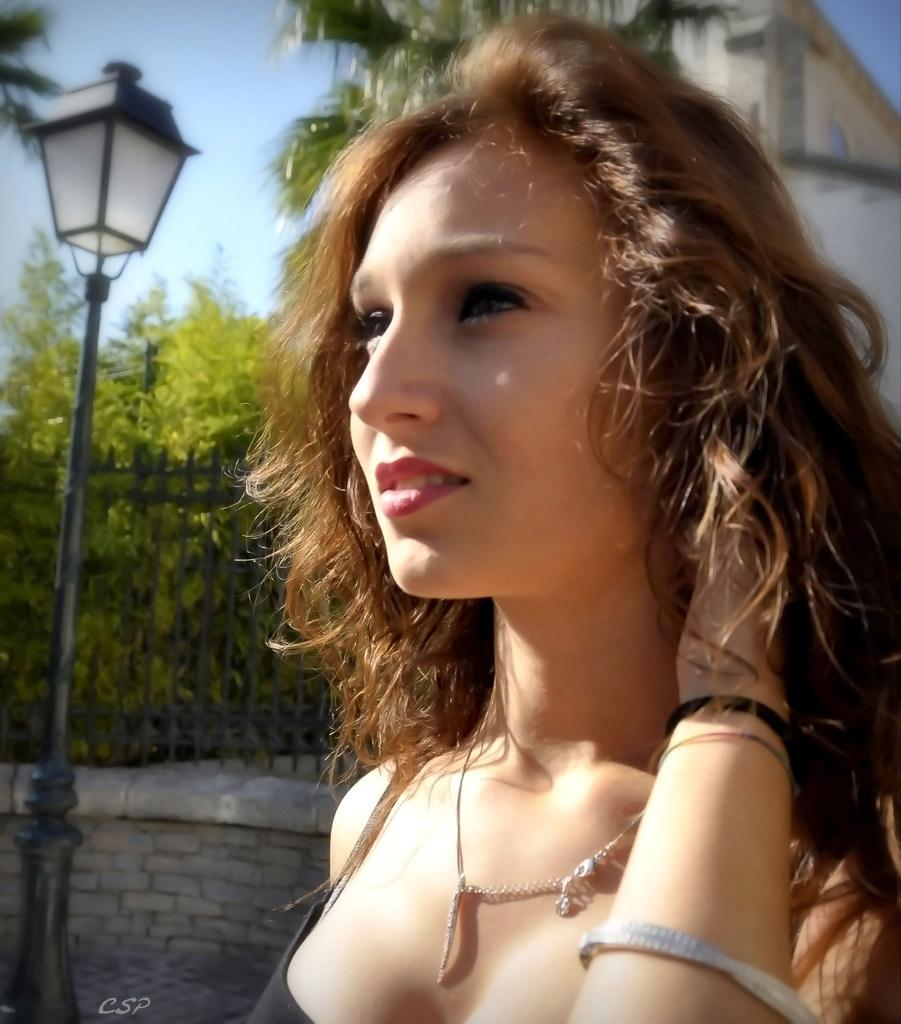Who is the main subject in the image? There is a girl in the image. What is located behind the girl? There is a street light behind the girl. What can be seen in the background of the image? There is a metal fence, trees, the sky, and a building visible in the background of the image. What type of history is being exchanged between the girl and the paper in the image? There is no paper present in the image, and therefore no exchange of history can be observed. 